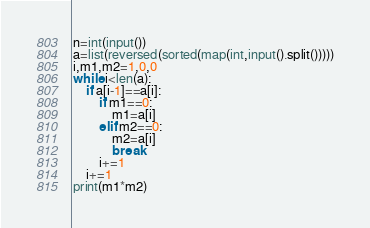<code> <loc_0><loc_0><loc_500><loc_500><_Python_>n=int(input())
a=list(reversed(sorted(map(int,input().split()))))
i,m1,m2=1,0,0
while i<len(a):
	if a[i-1]==a[i]:
		if m1==0: 
			m1=a[i]
		elif m2==0:
			m2=a[i]
			break
		i+=1
	i+=1
print(m1*m2)</code> 